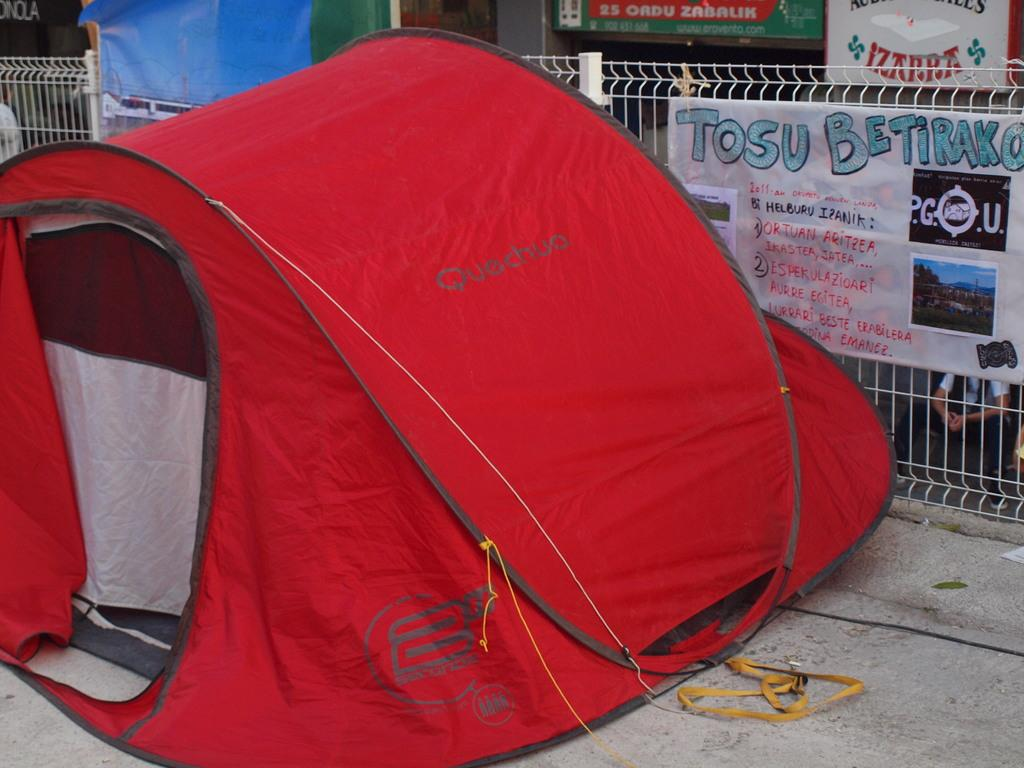What type of structure is present in the image? There is a tent in the image. What color is the tent? The tent is in red color. What other object can be seen on the right side of the image? There is an iron grill on the right side of the image. What type of nation is represented by the tent in the image? The image does not represent any specific nation; it simply shows a red tent and an iron grill. What kind of toys can be seen inside the tent in the image? There are no toys visible inside the tent in the image. 